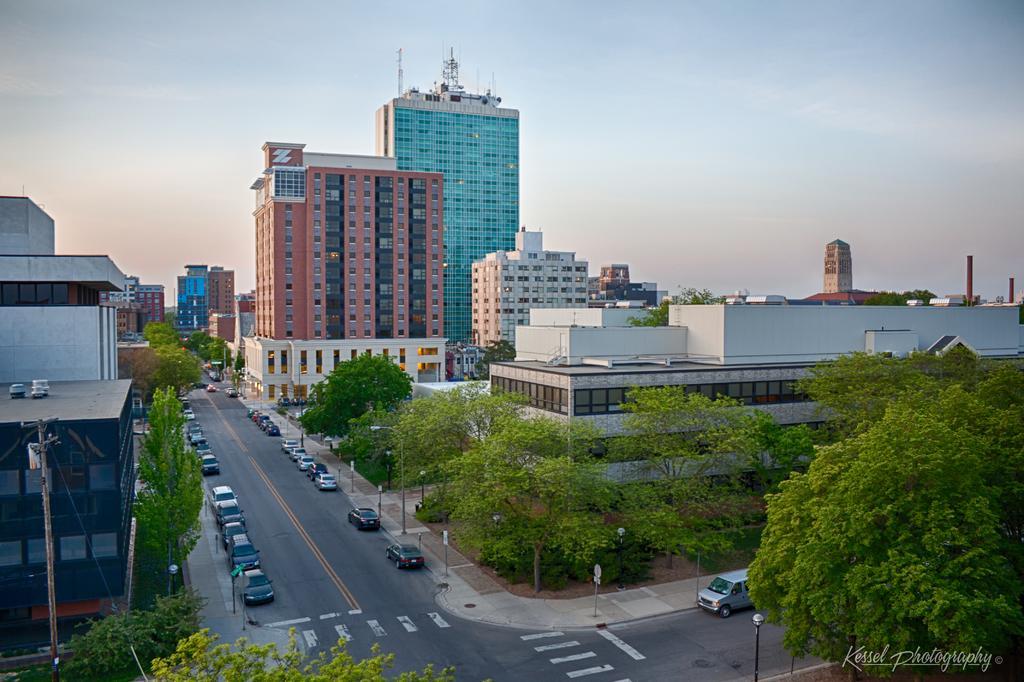Describe this image in one or two sentences. This picture shows few buildings and we see trees on the either side of the road and we see cars parked on both sides of the road and we see few sign boards on the sidewalk and few pole lights and an electrical pole and a blue cloudy sky. 